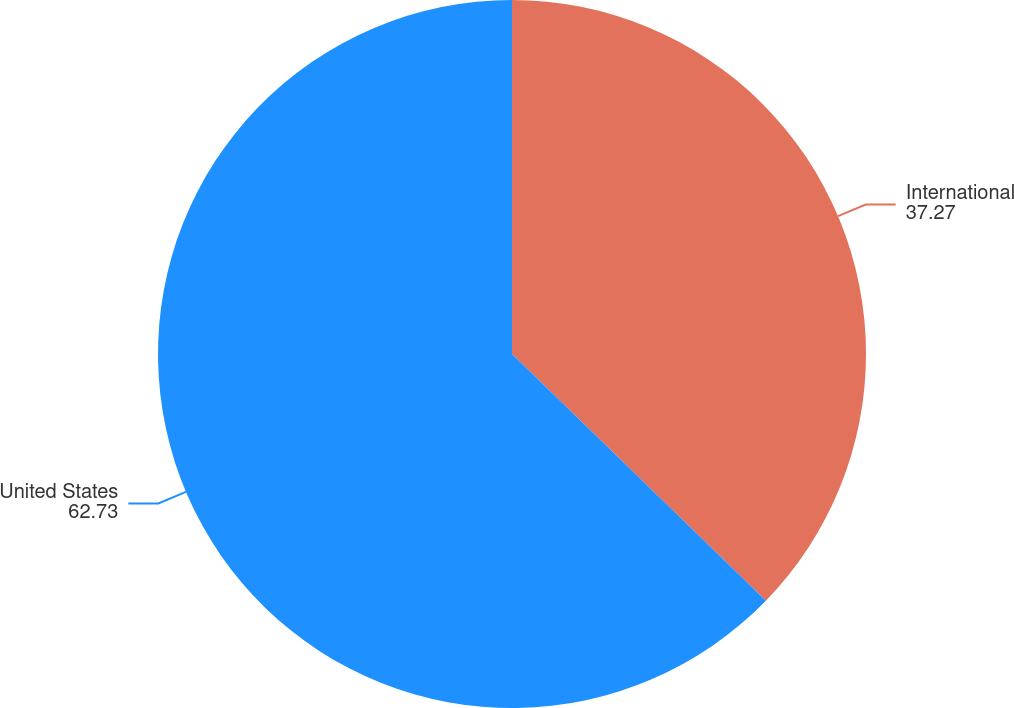Convert chart. <chart><loc_0><loc_0><loc_500><loc_500><pie_chart><fcel>International<fcel>United States<nl><fcel>37.27%<fcel>62.73%<nl></chart> 